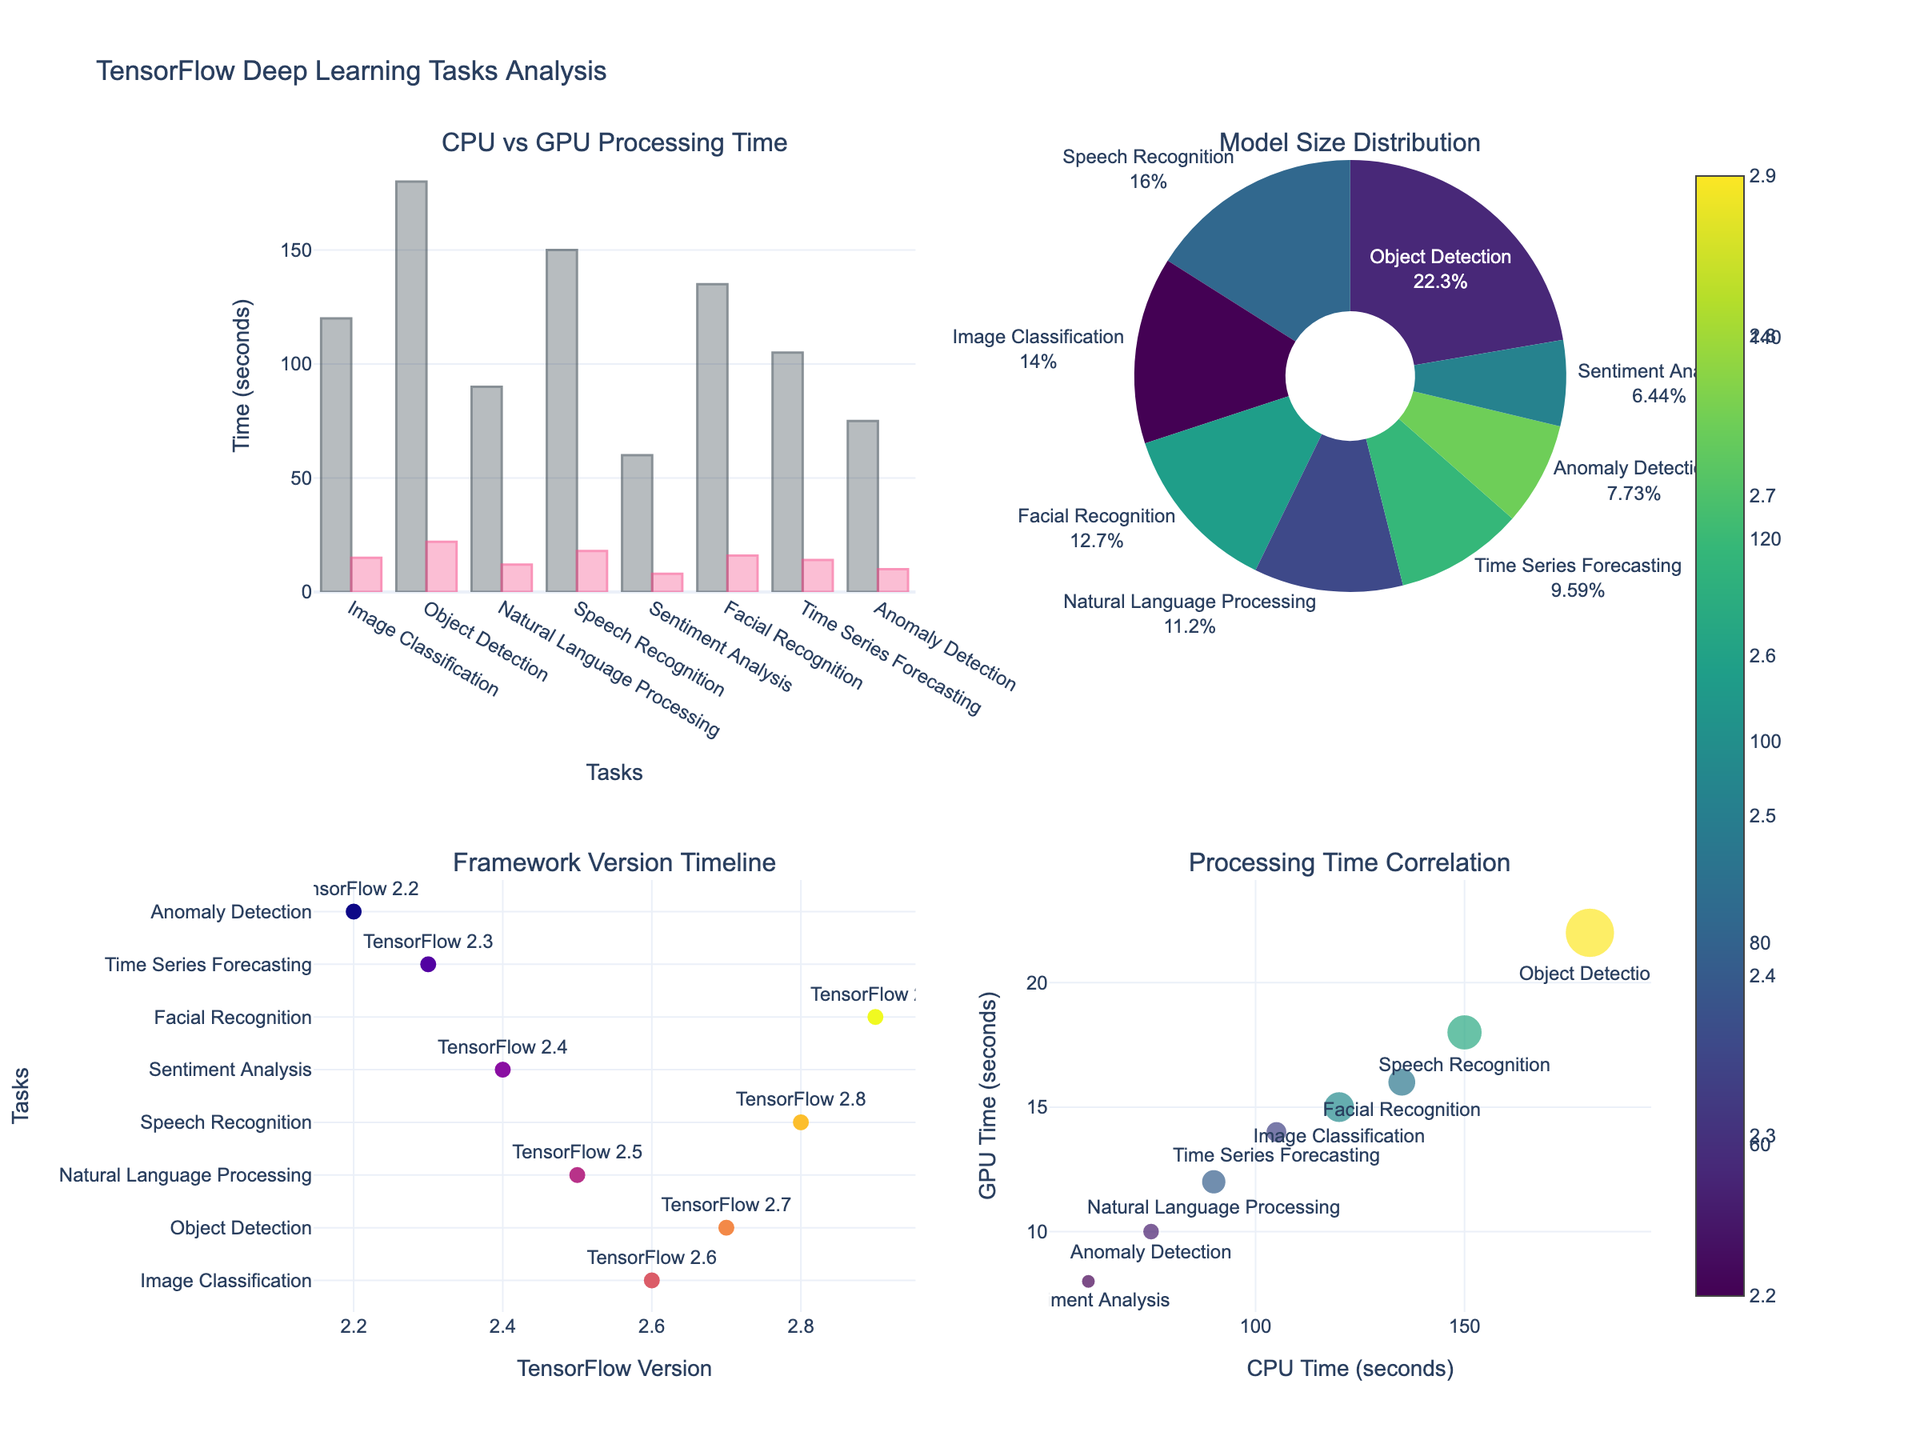What is the title of the figure? The title is located at the top of the figure, and it provides a concise summary of what the entire figure represents. In this case, it is "TensorFlow Deep Learning Tasks Analysis".
Answer: TensorFlow Deep Learning Tasks Analysis How many subplots are there in the figure? The layout of the figure shows that it is divided into four distinct sections, indicated by different titles and the 2x2 arrangement.
Answer: 4 Which task shows the highest CPU processing time? By examining the bar chart in the first subplot (CPU vs GPU Processing Time), the bar representing "Object Detection" reaches the highest value on the y-axis for CPU Time.
Answer: Object Detection Which framework version is associated with Natural Language Processing? The timeline scatter plot in the third subplot shows tasks plotted against different TensorFlow versions. Here, "Natural Language Processing" is labeled near the position representing version 2.5.
Answer: TensorFlow 2.5 What is the percentage of the model size for Image Classification in the pie chart? The pie chart shows the distribution of model sizes among different tasks. By looking at the segment labeled "Image Classification," we can see the percentage value.
Answer: % for Image Classification Which task has the smallest GPU processing time and what is it? In the bar chart comparing CPU vs GPU Processing Time, the bar representing "Sentiment Analysis" is the shortest for GPU Time. The time is 8 seconds.
Answer: Sentiment Analysis, 8 seconds Which task has the largest model size? The pie chart shows different segments representing model sizes. The segment with the largest size corresponds to "Object Detection," which is indicated by the size distribution and percentages.
Answer: Object Detection Is there a trend where tasks with higher CPU times also have higher GPU times? By examining the scatter plot in the last subplot (Processing Time Correlation), a positive correlation can be observed between CPU Time and GPU Time. Higher CPU times generally correspond to higher GPU times.
Answer: Yes What is the version with the most tasks performed? In the scatter plot representing the Framework Version Timeline, the version with the most tasks (highest number of markers) can be visually identified. This version is common among several tasks.
Answer: Look for multiple markers near a specific version Are there any tasks on the timeline that fall on the same TensorFlow framework version? We need to observe the scatter plot of tasks against TensorFlow framework version. Tasks sharing the same version align vertically on the same x-axis point.
Answer: Identify any common vertical alignments of task markers on the x-axis 